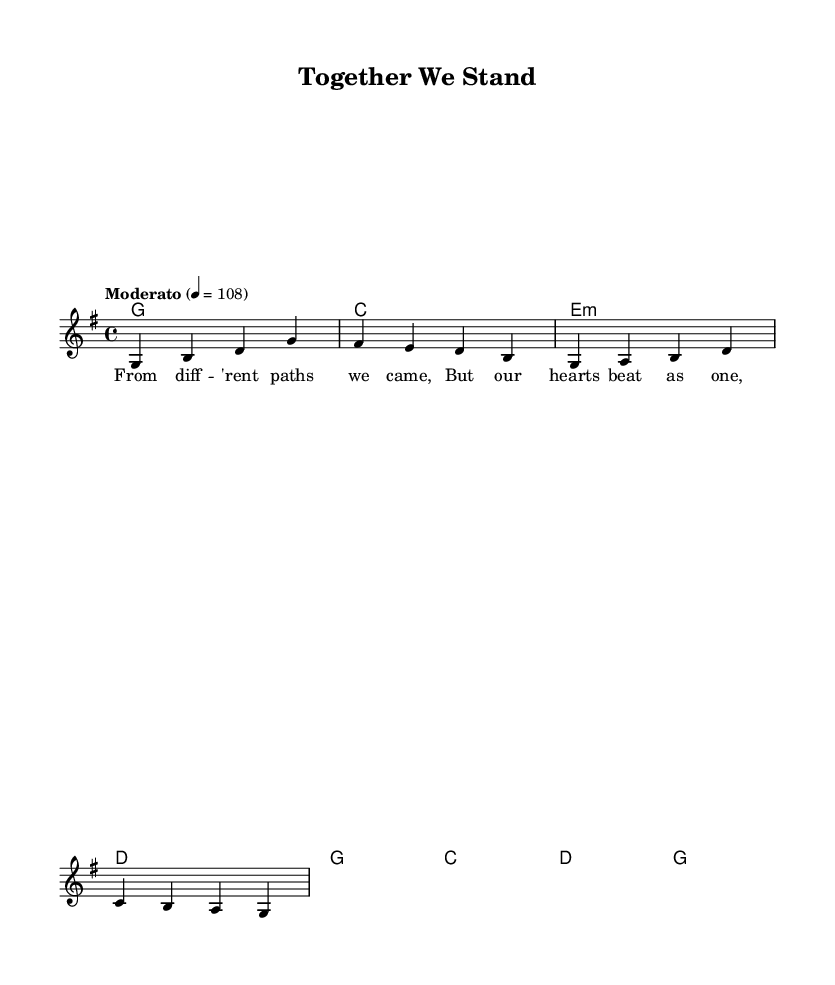What is the key signature of this music? The key signature is G major, which has one sharp (F#). This can be determined by looking at the global settings in the score, where it specifies "\key g \major".
Answer: G major What is the time signature of this music? The time signature is 4/4, which is indicated right after the key signature in the global settings with "\time 4/4". This indicates that each measure contains four beats, with each quarter note receiving one beat.
Answer: 4/4 What is the tempo marking? The tempo marking is "Moderato" with a speed of 108 beats per minute. This can be found in the global settings, specifically "\tempo "Moderato" 4 = 108".
Answer: Moderato What type of chord follows the initial G chord? The chord that follows the initial G chord is C major. This is seen in the harmonies section where the first chord is G and the second chord listed is C.
Answer: C What is the theme expressed in the lyrics? The theme expressed in the lyrics is unity. "From different paths we came, But our hearts beat as one" indicates a message of togetherness and acceptance, which is emphasized in the song's purpose.
Answer: Unity How does the structure of this song relate to Country Rock? The structure includes a focus on storytelling through lyrics and a simple chord progression, which are typical in Country Rock music. The use of common chord changes and relatable themes also support the genre's characteristics.
Answer: Storytelling 